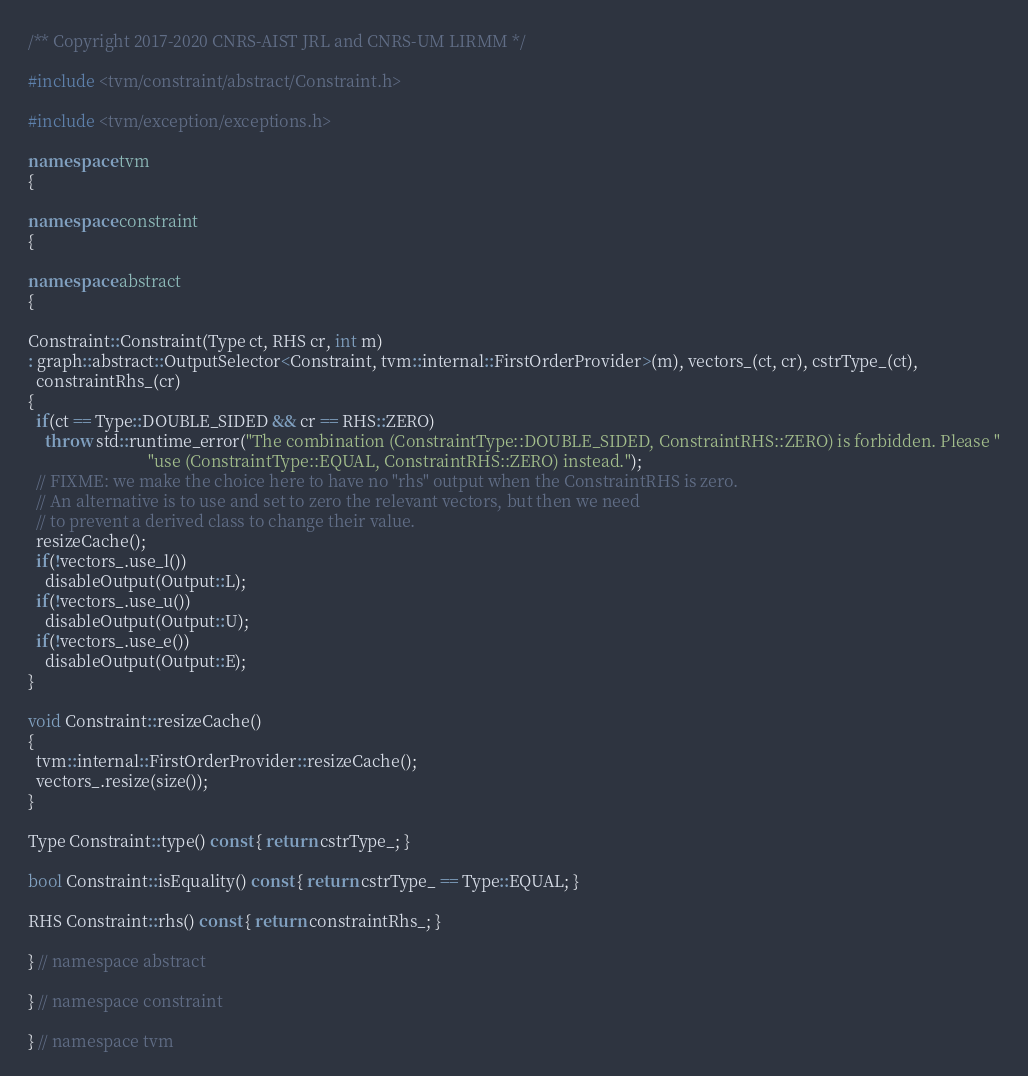<code> <loc_0><loc_0><loc_500><loc_500><_C++_>/** Copyright 2017-2020 CNRS-AIST JRL and CNRS-UM LIRMM */

#include <tvm/constraint/abstract/Constraint.h>

#include <tvm/exception/exceptions.h>

namespace tvm
{

namespace constraint
{

namespace abstract
{

Constraint::Constraint(Type ct, RHS cr, int m)
: graph::abstract::OutputSelector<Constraint, tvm::internal::FirstOrderProvider>(m), vectors_(ct, cr), cstrType_(ct),
  constraintRhs_(cr)
{
  if(ct == Type::DOUBLE_SIDED && cr == RHS::ZERO)
    throw std::runtime_error("The combination (ConstraintType::DOUBLE_SIDED, ConstraintRHS::ZERO) is forbidden. Please "
                             "use (ConstraintType::EQUAL, ConstraintRHS::ZERO) instead.");
  // FIXME: we make the choice here to have no "rhs" output when the ConstraintRHS is zero.
  // An alternative is to use and set to zero the relevant vectors, but then we need
  // to prevent a derived class to change their value.
  resizeCache();
  if(!vectors_.use_l())
    disableOutput(Output::L);
  if(!vectors_.use_u())
    disableOutput(Output::U);
  if(!vectors_.use_e())
    disableOutput(Output::E);
}

void Constraint::resizeCache()
{
  tvm::internal::FirstOrderProvider::resizeCache();
  vectors_.resize(size());
}

Type Constraint::type() const { return cstrType_; }

bool Constraint::isEquality() const { return cstrType_ == Type::EQUAL; }

RHS Constraint::rhs() const { return constraintRhs_; }

} // namespace abstract

} // namespace constraint

} // namespace tvm
</code> 